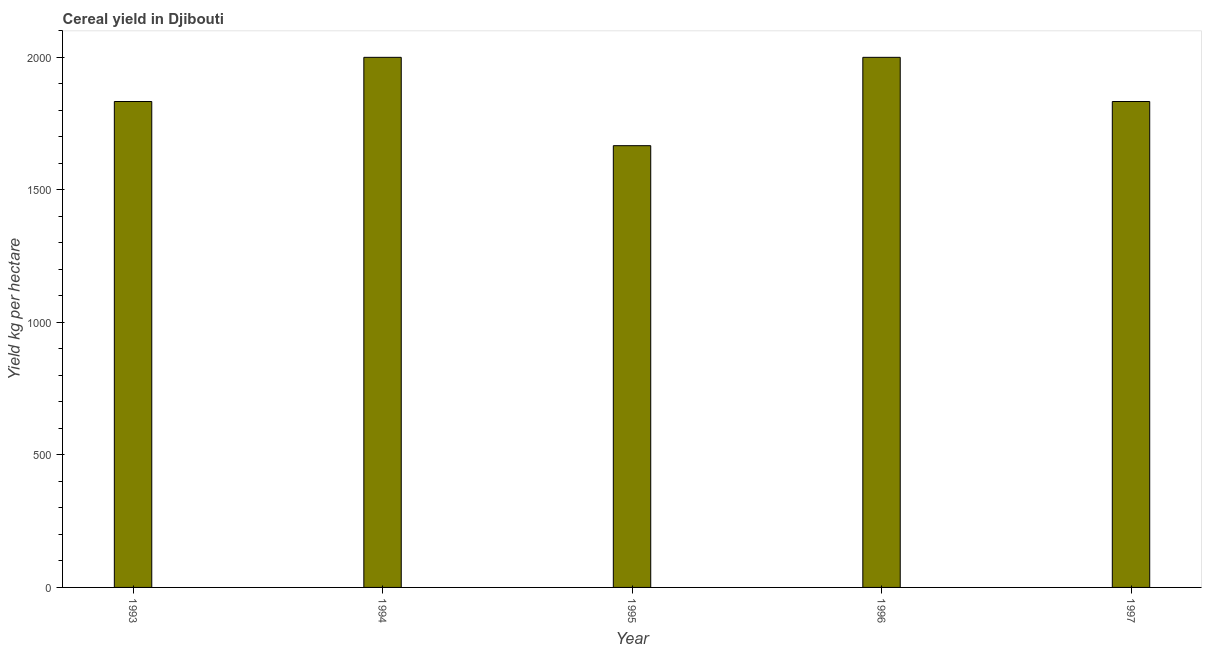What is the title of the graph?
Keep it short and to the point. Cereal yield in Djibouti. What is the label or title of the Y-axis?
Your response must be concise. Yield kg per hectare. What is the cereal yield in 1997?
Keep it short and to the point. 1833.33. Across all years, what is the maximum cereal yield?
Give a very brief answer. 2000. Across all years, what is the minimum cereal yield?
Provide a short and direct response. 1666.67. In which year was the cereal yield minimum?
Give a very brief answer. 1995. What is the sum of the cereal yield?
Keep it short and to the point. 9333.33. What is the difference between the cereal yield in 1996 and 1997?
Your answer should be compact. 166.67. What is the average cereal yield per year?
Keep it short and to the point. 1866.67. What is the median cereal yield?
Make the answer very short. 1833.33. In how many years, is the cereal yield greater than 1000 kg per hectare?
Provide a succinct answer. 5. What is the ratio of the cereal yield in 1993 to that in 1996?
Make the answer very short. 0.92. Is the difference between the cereal yield in 1994 and 1997 greater than the difference between any two years?
Make the answer very short. No. Is the sum of the cereal yield in 1995 and 1996 greater than the maximum cereal yield across all years?
Provide a succinct answer. Yes. What is the difference between the highest and the lowest cereal yield?
Provide a succinct answer. 333.33. In how many years, is the cereal yield greater than the average cereal yield taken over all years?
Make the answer very short. 2. How many years are there in the graph?
Offer a terse response. 5. What is the difference between two consecutive major ticks on the Y-axis?
Give a very brief answer. 500. What is the Yield kg per hectare of 1993?
Give a very brief answer. 1833.33. What is the Yield kg per hectare of 1995?
Make the answer very short. 1666.67. What is the Yield kg per hectare of 1996?
Provide a succinct answer. 2000. What is the Yield kg per hectare of 1997?
Your answer should be compact. 1833.33. What is the difference between the Yield kg per hectare in 1993 and 1994?
Make the answer very short. -166.67. What is the difference between the Yield kg per hectare in 1993 and 1995?
Keep it short and to the point. 166.67. What is the difference between the Yield kg per hectare in 1993 and 1996?
Ensure brevity in your answer.  -166.67. What is the difference between the Yield kg per hectare in 1994 and 1995?
Keep it short and to the point. 333.33. What is the difference between the Yield kg per hectare in 1994 and 1997?
Provide a short and direct response. 166.67. What is the difference between the Yield kg per hectare in 1995 and 1996?
Provide a succinct answer. -333.33. What is the difference between the Yield kg per hectare in 1995 and 1997?
Make the answer very short. -166.67. What is the difference between the Yield kg per hectare in 1996 and 1997?
Your response must be concise. 166.67. What is the ratio of the Yield kg per hectare in 1993 to that in 1994?
Offer a very short reply. 0.92. What is the ratio of the Yield kg per hectare in 1993 to that in 1995?
Your answer should be compact. 1.1. What is the ratio of the Yield kg per hectare in 1993 to that in 1996?
Make the answer very short. 0.92. What is the ratio of the Yield kg per hectare in 1994 to that in 1996?
Make the answer very short. 1. What is the ratio of the Yield kg per hectare in 1994 to that in 1997?
Provide a short and direct response. 1.09. What is the ratio of the Yield kg per hectare in 1995 to that in 1996?
Provide a short and direct response. 0.83. What is the ratio of the Yield kg per hectare in 1995 to that in 1997?
Ensure brevity in your answer.  0.91. What is the ratio of the Yield kg per hectare in 1996 to that in 1997?
Keep it short and to the point. 1.09. 